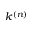Convert formula to latex. <formula><loc_0><loc_0><loc_500><loc_500>k ^ { ( n ) }</formula> 